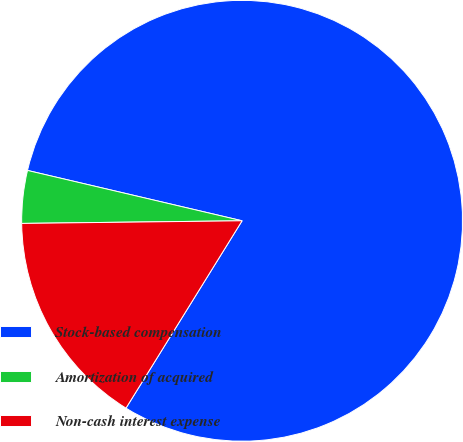<chart> <loc_0><loc_0><loc_500><loc_500><pie_chart><fcel>Stock-based compensation<fcel>Amortization of acquired<fcel>Non-cash interest expense<nl><fcel>80.17%<fcel>3.86%<fcel>15.98%<nl></chart> 